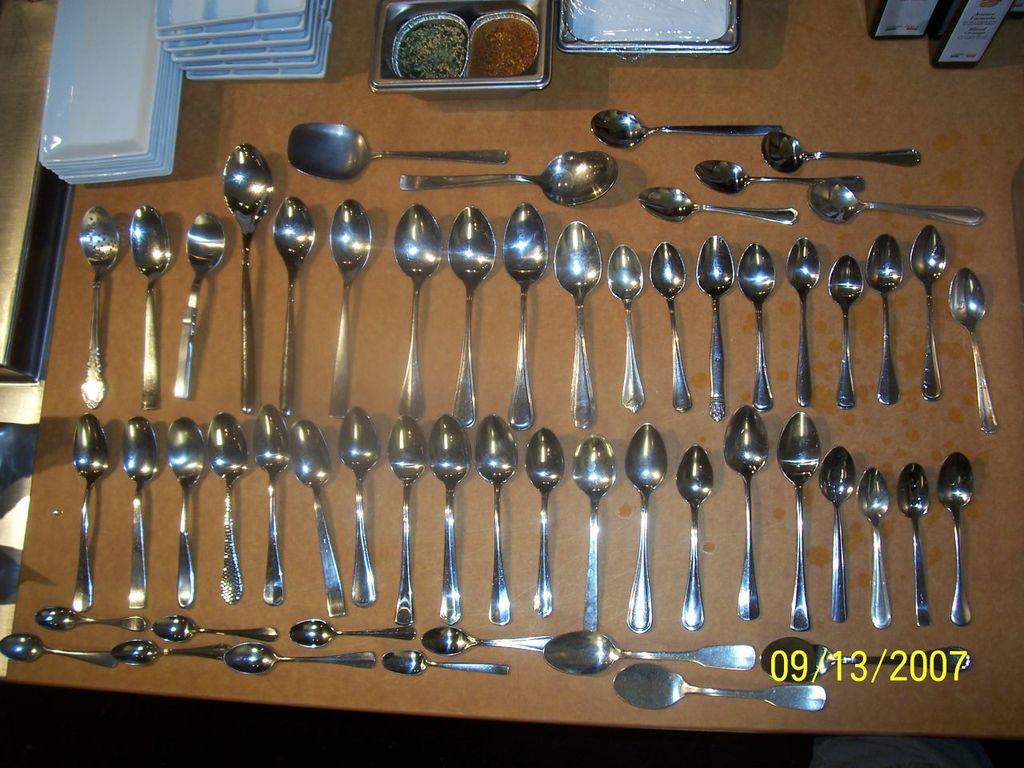What utensils can be seen in the image? There are spoons in the image. What type of dishware is present in the image? There are white plates in the image. What is being served on the plates? There are food items in the image. What is the color of the table in the image? The table in the image is brown. What type of pancake is being served on the brown table in the image? There is no pancake present in the image; the food items cannot be identified specifically. 